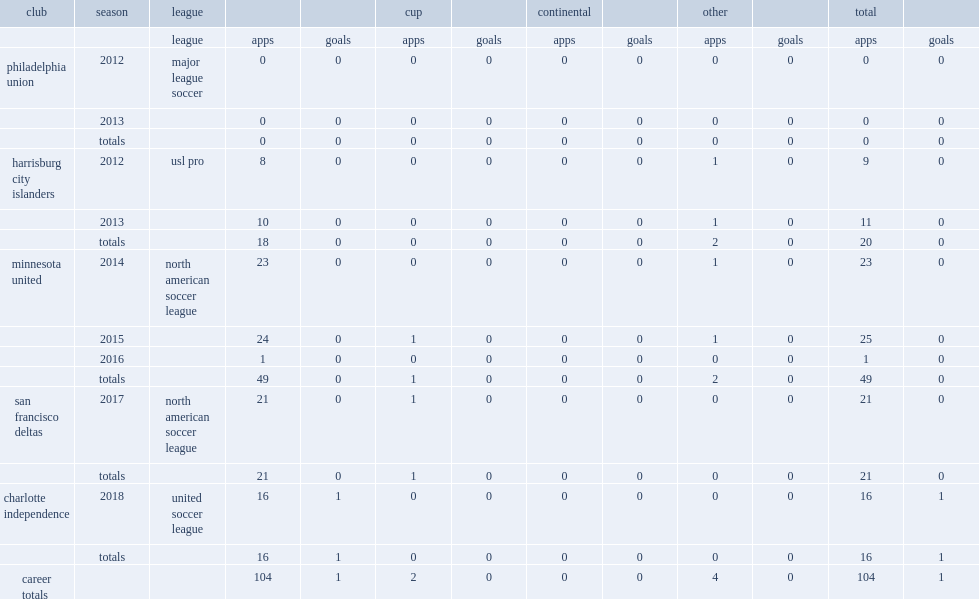In the 2014 season, which club did greg jordan join in north american soccer league? Minnesota united. Could you parse the entire table as a dict? {'header': ['club', 'season', 'league', '', '', 'cup', '', 'continental', '', 'other', '', 'total', ''], 'rows': [['', '', 'league', 'apps', 'goals', 'apps', 'goals', 'apps', 'goals', 'apps', 'goals', 'apps', 'goals'], ['philadelphia union', '2012', 'major league soccer', '0', '0', '0', '0', '0', '0', '0', '0', '0', '0'], ['', '2013', '', '0', '0', '0', '0', '0', '0', '0', '0', '0', '0'], ['', 'totals', '', '0', '0', '0', '0', '0', '0', '0', '0', '0', '0'], ['harrisburg city islanders', '2012', 'usl pro', '8', '0', '0', '0', '0', '0', '1', '0', '9', '0'], ['', '2013', '', '10', '0', '0', '0', '0', '0', '1', '0', '11', '0'], ['', 'totals', '', '18', '0', '0', '0', '0', '0', '2', '0', '20', '0'], ['minnesota united', '2014', 'north american soccer league', '23', '0', '0', '0', '0', '0', '1', '0', '23', '0'], ['', '2015', '', '24', '0', '1', '0', '0', '0', '1', '0', '25', '0'], ['', '2016', '', '1', '0', '0', '0', '0', '0', '0', '0', '1', '0'], ['', 'totals', '', '49', '0', '1', '0', '0', '0', '2', '0', '49', '0'], ['san francisco deltas', '2017', 'north american soccer league', '21', '0', '1', '0', '0', '0', '0', '0', '21', '0'], ['', 'totals', '', '21', '0', '1', '0', '0', '0', '0', '0', '21', '0'], ['charlotte independence', '2018', 'united soccer league', '16', '1', '0', '0', '0', '0', '0', '0', '16', '1'], ['', 'totals', '', '16', '1', '0', '0', '0', '0', '0', '0', '16', '1'], ['career totals', '', '', '104', '1', '2', '0', '0', '0', '4', '0', '104', '1']]} 